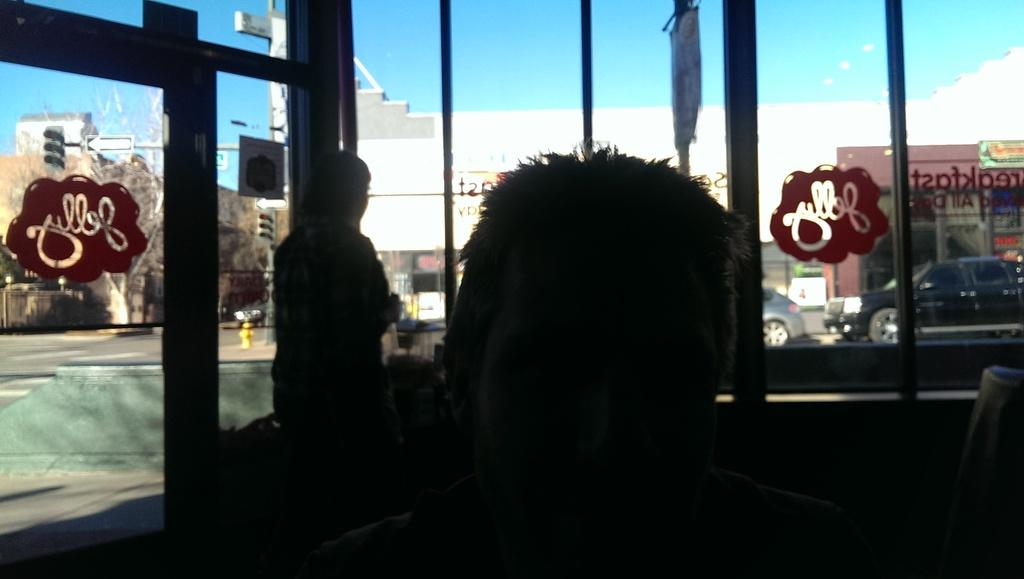How many people can be seen in the image? There are persons in the image, but the exact number is not specified. What objects are visible in the image? There are glasses and other objects visible in the image. What can be seen in the background of the image? There are buildings, vehicles, the sky, and a wall in the background of the image. Are there any other objects visible in the background of the image? Yes, there are other objects in the background of the image. What scientific experiment is being conducted by the persons in the image? There is no indication of a scientific experiment being conducted in the image. How many times do the persons in the image turn around? There is no information about the persons turning around in the image. 